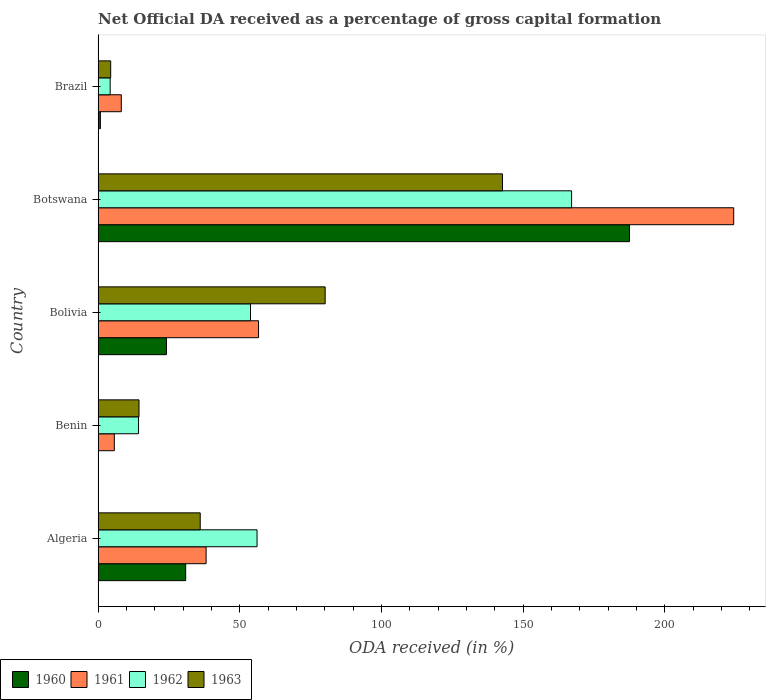How many different coloured bars are there?
Give a very brief answer. 4. Are the number of bars on each tick of the Y-axis equal?
Provide a short and direct response. Yes. How many bars are there on the 3rd tick from the top?
Keep it short and to the point. 4. In how many cases, is the number of bars for a given country not equal to the number of legend labels?
Your answer should be compact. 0. What is the net ODA received in 1963 in Algeria?
Your response must be concise. 36.04. Across all countries, what is the maximum net ODA received in 1960?
Provide a succinct answer. 187.49. Across all countries, what is the minimum net ODA received in 1963?
Ensure brevity in your answer.  4.45. In which country was the net ODA received in 1961 maximum?
Offer a very short reply. Botswana. In which country was the net ODA received in 1961 minimum?
Give a very brief answer. Benin. What is the total net ODA received in 1963 in the graph?
Provide a succinct answer. 277.72. What is the difference between the net ODA received in 1960 in Botswana and that in Brazil?
Your response must be concise. 186.68. What is the difference between the net ODA received in 1963 in Brazil and the net ODA received in 1962 in Benin?
Your answer should be compact. -9.83. What is the average net ODA received in 1960 per country?
Provide a succinct answer. 48.68. What is the difference between the net ODA received in 1960 and net ODA received in 1963 in Botswana?
Your answer should be compact. 44.81. What is the ratio of the net ODA received in 1963 in Algeria to that in Botswana?
Keep it short and to the point. 0.25. Is the difference between the net ODA received in 1960 in Bolivia and Botswana greater than the difference between the net ODA received in 1963 in Bolivia and Botswana?
Keep it short and to the point. No. What is the difference between the highest and the second highest net ODA received in 1960?
Offer a very short reply. 156.58. What is the difference between the highest and the lowest net ODA received in 1962?
Your response must be concise. 162.81. Is it the case that in every country, the sum of the net ODA received in 1962 and net ODA received in 1960 is greater than the sum of net ODA received in 1963 and net ODA received in 1961?
Provide a short and direct response. No. How many bars are there?
Offer a terse response. 20. How many countries are there in the graph?
Provide a succinct answer. 5. What is the difference between two consecutive major ticks on the X-axis?
Make the answer very short. 50. Does the graph contain any zero values?
Offer a very short reply. No. Does the graph contain grids?
Ensure brevity in your answer.  No. Where does the legend appear in the graph?
Offer a very short reply. Bottom left. What is the title of the graph?
Make the answer very short. Net Official DA received as a percentage of gross capital formation. Does "1965" appear as one of the legend labels in the graph?
Give a very brief answer. No. What is the label or title of the X-axis?
Offer a very short reply. ODA received (in %). What is the ODA received (in %) of 1960 in Algeria?
Offer a very short reply. 30.9. What is the ODA received (in %) of 1961 in Algeria?
Provide a succinct answer. 38.11. What is the ODA received (in %) in 1962 in Algeria?
Provide a succinct answer. 56.09. What is the ODA received (in %) of 1963 in Algeria?
Provide a short and direct response. 36.04. What is the ODA received (in %) in 1960 in Benin?
Your answer should be compact. 0.08. What is the ODA received (in %) of 1961 in Benin?
Your response must be concise. 5.73. What is the ODA received (in %) of 1962 in Benin?
Ensure brevity in your answer.  14.28. What is the ODA received (in %) in 1963 in Benin?
Your answer should be compact. 14.44. What is the ODA received (in %) of 1960 in Bolivia?
Ensure brevity in your answer.  24.12. What is the ODA received (in %) of 1961 in Bolivia?
Offer a terse response. 56.62. What is the ODA received (in %) of 1962 in Bolivia?
Provide a short and direct response. 53.77. What is the ODA received (in %) of 1963 in Bolivia?
Your answer should be compact. 80.11. What is the ODA received (in %) in 1960 in Botswana?
Provide a succinct answer. 187.49. What is the ODA received (in %) of 1961 in Botswana?
Your answer should be compact. 224.27. What is the ODA received (in %) in 1962 in Botswana?
Keep it short and to the point. 167.07. What is the ODA received (in %) in 1963 in Botswana?
Provide a short and direct response. 142.68. What is the ODA received (in %) in 1960 in Brazil?
Give a very brief answer. 0.81. What is the ODA received (in %) of 1961 in Brazil?
Your answer should be compact. 8.19. What is the ODA received (in %) of 1962 in Brazil?
Offer a very short reply. 4.26. What is the ODA received (in %) in 1963 in Brazil?
Make the answer very short. 4.45. Across all countries, what is the maximum ODA received (in %) in 1960?
Make the answer very short. 187.49. Across all countries, what is the maximum ODA received (in %) of 1961?
Provide a short and direct response. 224.27. Across all countries, what is the maximum ODA received (in %) of 1962?
Keep it short and to the point. 167.07. Across all countries, what is the maximum ODA received (in %) in 1963?
Give a very brief answer. 142.68. Across all countries, what is the minimum ODA received (in %) in 1960?
Provide a succinct answer. 0.08. Across all countries, what is the minimum ODA received (in %) of 1961?
Make the answer very short. 5.73. Across all countries, what is the minimum ODA received (in %) of 1962?
Your answer should be very brief. 4.26. Across all countries, what is the minimum ODA received (in %) in 1963?
Your answer should be very brief. 4.45. What is the total ODA received (in %) of 1960 in the graph?
Your answer should be very brief. 243.39. What is the total ODA received (in %) in 1961 in the graph?
Make the answer very short. 332.92. What is the total ODA received (in %) in 1962 in the graph?
Offer a terse response. 295.47. What is the total ODA received (in %) of 1963 in the graph?
Offer a very short reply. 277.72. What is the difference between the ODA received (in %) in 1960 in Algeria and that in Benin?
Provide a short and direct response. 30.82. What is the difference between the ODA received (in %) of 1961 in Algeria and that in Benin?
Offer a terse response. 32.39. What is the difference between the ODA received (in %) in 1962 in Algeria and that in Benin?
Ensure brevity in your answer.  41.81. What is the difference between the ODA received (in %) of 1963 in Algeria and that in Benin?
Offer a terse response. 21.6. What is the difference between the ODA received (in %) in 1960 in Algeria and that in Bolivia?
Ensure brevity in your answer.  6.78. What is the difference between the ODA received (in %) of 1961 in Algeria and that in Bolivia?
Provide a short and direct response. -18.5. What is the difference between the ODA received (in %) of 1962 in Algeria and that in Bolivia?
Keep it short and to the point. 2.31. What is the difference between the ODA received (in %) in 1963 in Algeria and that in Bolivia?
Ensure brevity in your answer.  -44.08. What is the difference between the ODA received (in %) in 1960 in Algeria and that in Botswana?
Your answer should be very brief. -156.58. What is the difference between the ODA received (in %) in 1961 in Algeria and that in Botswana?
Offer a terse response. -186.15. What is the difference between the ODA received (in %) of 1962 in Algeria and that in Botswana?
Offer a terse response. -110.98. What is the difference between the ODA received (in %) in 1963 in Algeria and that in Botswana?
Offer a terse response. -106.64. What is the difference between the ODA received (in %) in 1960 in Algeria and that in Brazil?
Make the answer very short. 30.09. What is the difference between the ODA received (in %) in 1961 in Algeria and that in Brazil?
Ensure brevity in your answer.  29.92. What is the difference between the ODA received (in %) in 1962 in Algeria and that in Brazil?
Offer a terse response. 51.83. What is the difference between the ODA received (in %) in 1963 in Algeria and that in Brazil?
Make the answer very short. 31.59. What is the difference between the ODA received (in %) of 1960 in Benin and that in Bolivia?
Make the answer very short. -24.04. What is the difference between the ODA received (in %) in 1961 in Benin and that in Bolivia?
Your response must be concise. -50.89. What is the difference between the ODA received (in %) of 1962 in Benin and that in Bolivia?
Give a very brief answer. -39.5. What is the difference between the ODA received (in %) of 1963 in Benin and that in Bolivia?
Ensure brevity in your answer.  -65.67. What is the difference between the ODA received (in %) of 1960 in Benin and that in Botswana?
Keep it short and to the point. -187.41. What is the difference between the ODA received (in %) in 1961 in Benin and that in Botswana?
Ensure brevity in your answer.  -218.54. What is the difference between the ODA received (in %) in 1962 in Benin and that in Botswana?
Ensure brevity in your answer.  -152.79. What is the difference between the ODA received (in %) of 1963 in Benin and that in Botswana?
Ensure brevity in your answer.  -128.24. What is the difference between the ODA received (in %) of 1960 in Benin and that in Brazil?
Ensure brevity in your answer.  -0.73. What is the difference between the ODA received (in %) in 1961 in Benin and that in Brazil?
Give a very brief answer. -2.46. What is the difference between the ODA received (in %) of 1962 in Benin and that in Brazil?
Your answer should be very brief. 10.01. What is the difference between the ODA received (in %) in 1963 in Benin and that in Brazil?
Provide a short and direct response. 9.99. What is the difference between the ODA received (in %) in 1960 in Bolivia and that in Botswana?
Your response must be concise. -163.37. What is the difference between the ODA received (in %) of 1961 in Bolivia and that in Botswana?
Ensure brevity in your answer.  -167.65. What is the difference between the ODA received (in %) in 1962 in Bolivia and that in Botswana?
Make the answer very short. -113.3. What is the difference between the ODA received (in %) of 1963 in Bolivia and that in Botswana?
Offer a very short reply. -62.56. What is the difference between the ODA received (in %) of 1960 in Bolivia and that in Brazil?
Your response must be concise. 23.31. What is the difference between the ODA received (in %) in 1961 in Bolivia and that in Brazil?
Offer a very short reply. 48.42. What is the difference between the ODA received (in %) in 1962 in Bolivia and that in Brazil?
Offer a terse response. 49.51. What is the difference between the ODA received (in %) of 1963 in Bolivia and that in Brazil?
Keep it short and to the point. 75.67. What is the difference between the ODA received (in %) in 1960 in Botswana and that in Brazil?
Provide a succinct answer. 186.68. What is the difference between the ODA received (in %) of 1961 in Botswana and that in Brazil?
Provide a short and direct response. 216.07. What is the difference between the ODA received (in %) of 1962 in Botswana and that in Brazil?
Keep it short and to the point. 162.81. What is the difference between the ODA received (in %) of 1963 in Botswana and that in Brazil?
Your answer should be very brief. 138.23. What is the difference between the ODA received (in %) of 1960 in Algeria and the ODA received (in %) of 1961 in Benin?
Keep it short and to the point. 25.17. What is the difference between the ODA received (in %) in 1960 in Algeria and the ODA received (in %) in 1962 in Benin?
Keep it short and to the point. 16.62. What is the difference between the ODA received (in %) of 1960 in Algeria and the ODA received (in %) of 1963 in Benin?
Provide a succinct answer. 16.46. What is the difference between the ODA received (in %) of 1961 in Algeria and the ODA received (in %) of 1962 in Benin?
Your response must be concise. 23.84. What is the difference between the ODA received (in %) in 1961 in Algeria and the ODA received (in %) in 1963 in Benin?
Offer a very short reply. 23.67. What is the difference between the ODA received (in %) in 1962 in Algeria and the ODA received (in %) in 1963 in Benin?
Keep it short and to the point. 41.65. What is the difference between the ODA received (in %) of 1960 in Algeria and the ODA received (in %) of 1961 in Bolivia?
Provide a short and direct response. -25.71. What is the difference between the ODA received (in %) in 1960 in Algeria and the ODA received (in %) in 1962 in Bolivia?
Your answer should be very brief. -22.87. What is the difference between the ODA received (in %) of 1960 in Algeria and the ODA received (in %) of 1963 in Bolivia?
Your answer should be very brief. -49.21. What is the difference between the ODA received (in %) in 1961 in Algeria and the ODA received (in %) in 1962 in Bolivia?
Give a very brief answer. -15.66. What is the difference between the ODA received (in %) of 1961 in Algeria and the ODA received (in %) of 1963 in Bolivia?
Make the answer very short. -42. What is the difference between the ODA received (in %) in 1962 in Algeria and the ODA received (in %) in 1963 in Bolivia?
Your response must be concise. -24.03. What is the difference between the ODA received (in %) of 1960 in Algeria and the ODA received (in %) of 1961 in Botswana?
Your answer should be very brief. -193.36. What is the difference between the ODA received (in %) of 1960 in Algeria and the ODA received (in %) of 1962 in Botswana?
Offer a terse response. -136.17. What is the difference between the ODA received (in %) in 1960 in Algeria and the ODA received (in %) in 1963 in Botswana?
Offer a very short reply. -111.78. What is the difference between the ODA received (in %) of 1961 in Algeria and the ODA received (in %) of 1962 in Botswana?
Your answer should be compact. -128.96. What is the difference between the ODA received (in %) in 1961 in Algeria and the ODA received (in %) in 1963 in Botswana?
Provide a short and direct response. -104.56. What is the difference between the ODA received (in %) in 1962 in Algeria and the ODA received (in %) in 1963 in Botswana?
Ensure brevity in your answer.  -86.59. What is the difference between the ODA received (in %) in 1960 in Algeria and the ODA received (in %) in 1961 in Brazil?
Offer a terse response. 22.71. What is the difference between the ODA received (in %) of 1960 in Algeria and the ODA received (in %) of 1962 in Brazil?
Provide a short and direct response. 26.64. What is the difference between the ODA received (in %) of 1960 in Algeria and the ODA received (in %) of 1963 in Brazil?
Make the answer very short. 26.45. What is the difference between the ODA received (in %) in 1961 in Algeria and the ODA received (in %) in 1962 in Brazil?
Ensure brevity in your answer.  33.85. What is the difference between the ODA received (in %) of 1961 in Algeria and the ODA received (in %) of 1963 in Brazil?
Provide a short and direct response. 33.67. What is the difference between the ODA received (in %) of 1962 in Algeria and the ODA received (in %) of 1963 in Brazil?
Provide a short and direct response. 51.64. What is the difference between the ODA received (in %) of 1960 in Benin and the ODA received (in %) of 1961 in Bolivia?
Your response must be concise. -56.54. What is the difference between the ODA received (in %) of 1960 in Benin and the ODA received (in %) of 1962 in Bolivia?
Keep it short and to the point. -53.7. What is the difference between the ODA received (in %) of 1960 in Benin and the ODA received (in %) of 1963 in Bolivia?
Ensure brevity in your answer.  -80.04. What is the difference between the ODA received (in %) of 1961 in Benin and the ODA received (in %) of 1962 in Bolivia?
Provide a succinct answer. -48.05. What is the difference between the ODA received (in %) of 1961 in Benin and the ODA received (in %) of 1963 in Bolivia?
Offer a very short reply. -74.39. What is the difference between the ODA received (in %) of 1962 in Benin and the ODA received (in %) of 1963 in Bolivia?
Make the answer very short. -65.84. What is the difference between the ODA received (in %) of 1960 in Benin and the ODA received (in %) of 1961 in Botswana?
Ensure brevity in your answer.  -224.19. What is the difference between the ODA received (in %) in 1960 in Benin and the ODA received (in %) in 1962 in Botswana?
Your answer should be compact. -166.99. What is the difference between the ODA received (in %) in 1960 in Benin and the ODA received (in %) in 1963 in Botswana?
Your answer should be very brief. -142.6. What is the difference between the ODA received (in %) in 1961 in Benin and the ODA received (in %) in 1962 in Botswana?
Provide a short and direct response. -161.34. What is the difference between the ODA received (in %) in 1961 in Benin and the ODA received (in %) in 1963 in Botswana?
Your response must be concise. -136.95. What is the difference between the ODA received (in %) of 1962 in Benin and the ODA received (in %) of 1963 in Botswana?
Give a very brief answer. -128.4. What is the difference between the ODA received (in %) in 1960 in Benin and the ODA received (in %) in 1961 in Brazil?
Give a very brief answer. -8.11. What is the difference between the ODA received (in %) of 1960 in Benin and the ODA received (in %) of 1962 in Brazil?
Give a very brief answer. -4.19. What is the difference between the ODA received (in %) in 1960 in Benin and the ODA received (in %) in 1963 in Brazil?
Provide a short and direct response. -4.37. What is the difference between the ODA received (in %) in 1961 in Benin and the ODA received (in %) in 1962 in Brazil?
Give a very brief answer. 1.46. What is the difference between the ODA received (in %) in 1961 in Benin and the ODA received (in %) in 1963 in Brazil?
Ensure brevity in your answer.  1.28. What is the difference between the ODA received (in %) in 1962 in Benin and the ODA received (in %) in 1963 in Brazil?
Make the answer very short. 9.83. What is the difference between the ODA received (in %) of 1960 in Bolivia and the ODA received (in %) of 1961 in Botswana?
Make the answer very short. -200.15. What is the difference between the ODA received (in %) of 1960 in Bolivia and the ODA received (in %) of 1962 in Botswana?
Your response must be concise. -142.95. What is the difference between the ODA received (in %) of 1960 in Bolivia and the ODA received (in %) of 1963 in Botswana?
Provide a succinct answer. -118.56. What is the difference between the ODA received (in %) in 1961 in Bolivia and the ODA received (in %) in 1962 in Botswana?
Ensure brevity in your answer.  -110.45. What is the difference between the ODA received (in %) of 1961 in Bolivia and the ODA received (in %) of 1963 in Botswana?
Your response must be concise. -86.06. What is the difference between the ODA received (in %) in 1962 in Bolivia and the ODA received (in %) in 1963 in Botswana?
Ensure brevity in your answer.  -88.9. What is the difference between the ODA received (in %) of 1960 in Bolivia and the ODA received (in %) of 1961 in Brazil?
Offer a very short reply. 15.93. What is the difference between the ODA received (in %) of 1960 in Bolivia and the ODA received (in %) of 1962 in Brazil?
Give a very brief answer. 19.86. What is the difference between the ODA received (in %) of 1960 in Bolivia and the ODA received (in %) of 1963 in Brazil?
Keep it short and to the point. 19.67. What is the difference between the ODA received (in %) in 1961 in Bolivia and the ODA received (in %) in 1962 in Brazil?
Ensure brevity in your answer.  52.35. What is the difference between the ODA received (in %) of 1961 in Bolivia and the ODA received (in %) of 1963 in Brazil?
Your answer should be compact. 52.17. What is the difference between the ODA received (in %) of 1962 in Bolivia and the ODA received (in %) of 1963 in Brazil?
Your response must be concise. 49.33. What is the difference between the ODA received (in %) of 1960 in Botswana and the ODA received (in %) of 1961 in Brazil?
Give a very brief answer. 179.29. What is the difference between the ODA received (in %) in 1960 in Botswana and the ODA received (in %) in 1962 in Brazil?
Provide a short and direct response. 183.22. What is the difference between the ODA received (in %) in 1960 in Botswana and the ODA received (in %) in 1963 in Brazil?
Provide a succinct answer. 183.04. What is the difference between the ODA received (in %) of 1961 in Botswana and the ODA received (in %) of 1962 in Brazil?
Your answer should be very brief. 220. What is the difference between the ODA received (in %) in 1961 in Botswana and the ODA received (in %) in 1963 in Brazil?
Offer a terse response. 219.82. What is the difference between the ODA received (in %) in 1962 in Botswana and the ODA received (in %) in 1963 in Brazil?
Ensure brevity in your answer.  162.62. What is the average ODA received (in %) of 1960 per country?
Offer a terse response. 48.68. What is the average ODA received (in %) in 1961 per country?
Provide a succinct answer. 66.58. What is the average ODA received (in %) of 1962 per country?
Provide a short and direct response. 59.09. What is the average ODA received (in %) in 1963 per country?
Provide a short and direct response. 55.54. What is the difference between the ODA received (in %) in 1960 and ODA received (in %) in 1961 in Algeria?
Provide a short and direct response. -7.21. What is the difference between the ODA received (in %) of 1960 and ODA received (in %) of 1962 in Algeria?
Your response must be concise. -25.19. What is the difference between the ODA received (in %) of 1960 and ODA received (in %) of 1963 in Algeria?
Provide a short and direct response. -5.14. What is the difference between the ODA received (in %) of 1961 and ODA received (in %) of 1962 in Algeria?
Make the answer very short. -17.98. What is the difference between the ODA received (in %) in 1961 and ODA received (in %) in 1963 in Algeria?
Make the answer very short. 2.08. What is the difference between the ODA received (in %) in 1962 and ODA received (in %) in 1963 in Algeria?
Offer a very short reply. 20.05. What is the difference between the ODA received (in %) of 1960 and ODA received (in %) of 1961 in Benin?
Your response must be concise. -5.65. What is the difference between the ODA received (in %) in 1960 and ODA received (in %) in 1962 in Benin?
Provide a succinct answer. -14.2. What is the difference between the ODA received (in %) of 1960 and ODA received (in %) of 1963 in Benin?
Your response must be concise. -14.36. What is the difference between the ODA received (in %) in 1961 and ODA received (in %) in 1962 in Benin?
Ensure brevity in your answer.  -8.55. What is the difference between the ODA received (in %) in 1961 and ODA received (in %) in 1963 in Benin?
Make the answer very short. -8.71. What is the difference between the ODA received (in %) in 1962 and ODA received (in %) in 1963 in Benin?
Keep it short and to the point. -0.16. What is the difference between the ODA received (in %) of 1960 and ODA received (in %) of 1961 in Bolivia?
Your response must be concise. -32.5. What is the difference between the ODA received (in %) in 1960 and ODA received (in %) in 1962 in Bolivia?
Your answer should be compact. -29.66. What is the difference between the ODA received (in %) of 1960 and ODA received (in %) of 1963 in Bolivia?
Offer a terse response. -56. What is the difference between the ODA received (in %) in 1961 and ODA received (in %) in 1962 in Bolivia?
Make the answer very short. 2.84. What is the difference between the ODA received (in %) in 1961 and ODA received (in %) in 1963 in Bolivia?
Your answer should be compact. -23.5. What is the difference between the ODA received (in %) in 1962 and ODA received (in %) in 1963 in Bolivia?
Make the answer very short. -26.34. What is the difference between the ODA received (in %) of 1960 and ODA received (in %) of 1961 in Botswana?
Make the answer very short. -36.78. What is the difference between the ODA received (in %) in 1960 and ODA received (in %) in 1962 in Botswana?
Ensure brevity in your answer.  20.42. What is the difference between the ODA received (in %) in 1960 and ODA received (in %) in 1963 in Botswana?
Your response must be concise. 44.81. What is the difference between the ODA received (in %) in 1961 and ODA received (in %) in 1962 in Botswana?
Provide a short and direct response. 57.2. What is the difference between the ODA received (in %) in 1961 and ODA received (in %) in 1963 in Botswana?
Your response must be concise. 81.59. What is the difference between the ODA received (in %) of 1962 and ODA received (in %) of 1963 in Botswana?
Your answer should be very brief. 24.39. What is the difference between the ODA received (in %) of 1960 and ODA received (in %) of 1961 in Brazil?
Your answer should be very brief. -7.38. What is the difference between the ODA received (in %) in 1960 and ODA received (in %) in 1962 in Brazil?
Your response must be concise. -3.46. What is the difference between the ODA received (in %) in 1960 and ODA received (in %) in 1963 in Brazil?
Offer a very short reply. -3.64. What is the difference between the ODA received (in %) in 1961 and ODA received (in %) in 1962 in Brazil?
Your response must be concise. 3.93. What is the difference between the ODA received (in %) of 1961 and ODA received (in %) of 1963 in Brazil?
Your response must be concise. 3.74. What is the difference between the ODA received (in %) of 1962 and ODA received (in %) of 1963 in Brazil?
Your answer should be compact. -0.18. What is the ratio of the ODA received (in %) in 1960 in Algeria to that in Benin?
Your answer should be very brief. 399.3. What is the ratio of the ODA received (in %) of 1961 in Algeria to that in Benin?
Your answer should be compact. 6.65. What is the ratio of the ODA received (in %) of 1962 in Algeria to that in Benin?
Your answer should be compact. 3.93. What is the ratio of the ODA received (in %) of 1963 in Algeria to that in Benin?
Keep it short and to the point. 2.5. What is the ratio of the ODA received (in %) in 1960 in Algeria to that in Bolivia?
Make the answer very short. 1.28. What is the ratio of the ODA received (in %) of 1961 in Algeria to that in Bolivia?
Your answer should be very brief. 0.67. What is the ratio of the ODA received (in %) of 1962 in Algeria to that in Bolivia?
Make the answer very short. 1.04. What is the ratio of the ODA received (in %) of 1963 in Algeria to that in Bolivia?
Provide a succinct answer. 0.45. What is the ratio of the ODA received (in %) in 1960 in Algeria to that in Botswana?
Your answer should be very brief. 0.16. What is the ratio of the ODA received (in %) in 1961 in Algeria to that in Botswana?
Keep it short and to the point. 0.17. What is the ratio of the ODA received (in %) in 1962 in Algeria to that in Botswana?
Provide a succinct answer. 0.34. What is the ratio of the ODA received (in %) in 1963 in Algeria to that in Botswana?
Your answer should be compact. 0.25. What is the ratio of the ODA received (in %) of 1960 in Algeria to that in Brazil?
Your answer should be compact. 38.25. What is the ratio of the ODA received (in %) of 1961 in Algeria to that in Brazil?
Ensure brevity in your answer.  4.65. What is the ratio of the ODA received (in %) in 1962 in Algeria to that in Brazil?
Give a very brief answer. 13.15. What is the ratio of the ODA received (in %) in 1963 in Algeria to that in Brazil?
Offer a terse response. 8.1. What is the ratio of the ODA received (in %) of 1960 in Benin to that in Bolivia?
Offer a terse response. 0. What is the ratio of the ODA received (in %) of 1961 in Benin to that in Bolivia?
Ensure brevity in your answer.  0.1. What is the ratio of the ODA received (in %) in 1962 in Benin to that in Bolivia?
Your answer should be very brief. 0.27. What is the ratio of the ODA received (in %) of 1963 in Benin to that in Bolivia?
Keep it short and to the point. 0.18. What is the ratio of the ODA received (in %) of 1960 in Benin to that in Botswana?
Make the answer very short. 0. What is the ratio of the ODA received (in %) in 1961 in Benin to that in Botswana?
Keep it short and to the point. 0.03. What is the ratio of the ODA received (in %) of 1962 in Benin to that in Botswana?
Offer a very short reply. 0.09. What is the ratio of the ODA received (in %) of 1963 in Benin to that in Botswana?
Give a very brief answer. 0.1. What is the ratio of the ODA received (in %) of 1960 in Benin to that in Brazil?
Provide a succinct answer. 0.1. What is the ratio of the ODA received (in %) in 1961 in Benin to that in Brazil?
Your answer should be very brief. 0.7. What is the ratio of the ODA received (in %) of 1962 in Benin to that in Brazil?
Provide a succinct answer. 3.35. What is the ratio of the ODA received (in %) of 1963 in Benin to that in Brazil?
Offer a terse response. 3.25. What is the ratio of the ODA received (in %) in 1960 in Bolivia to that in Botswana?
Your response must be concise. 0.13. What is the ratio of the ODA received (in %) of 1961 in Bolivia to that in Botswana?
Your answer should be compact. 0.25. What is the ratio of the ODA received (in %) in 1962 in Bolivia to that in Botswana?
Give a very brief answer. 0.32. What is the ratio of the ODA received (in %) of 1963 in Bolivia to that in Botswana?
Your answer should be very brief. 0.56. What is the ratio of the ODA received (in %) of 1960 in Bolivia to that in Brazil?
Ensure brevity in your answer.  29.85. What is the ratio of the ODA received (in %) of 1961 in Bolivia to that in Brazil?
Provide a short and direct response. 6.91. What is the ratio of the ODA received (in %) in 1962 in Bolivia to that in Brazil?
Your answer should be compact. 12.61. What is the ratio of the ODA received (in %) of 1963 in Bolivia to that in Brazil?
Provide a succinct answer. 18.01. What is the ratio of the ODA received (in %) in 1960 in Botswana to that in Brazil?
Make the answer very short. 232.07. What is the ratio of the ODA received (in %) of 1961 in Botswana to that in Brazil?
Provide a succinct answer. 27.38. What is the ratio of the ODA received (in %) in 1962 in Botswana to that in Brazil?
Provide a short and direct response. 39.18. What is the ratio of the ODA received (in %) of 1963 in Botswana to that in Brazil?
Ensure brevity in your answer.  32.07. What is the difference between the highest and the second highest ODA received (in %) in 1960?
Provide a succinct answer. 156.58. What is the difference between the highest and the second highest ODA received (in %) of 1961?
Your answer should be very brief. 167.65. What is the difference between the highest and the second highest ODA received (in %) in 1962?
Give a very brief answer. 110.98. What is the difference between the highest and the second highest ODA received (in %) in 1963?
Your answer should be compact. 62.56. What is the difference between the highest and the lowest ODA received (in %) of 1960?
Ensure brevity in your answer.  187.41. What is the difference between the highest and the lowest ODA received (in %) in 1961?
Keep it short and to the point. 218.54. What is the difference between the highest and the lowest ODA received (in %) in 1962?
Offer a very short reply. 162.81. What is the difference between the highest and the lowest ODA received (in %) in 1963?
Provide a succinct answer. 138.23. 